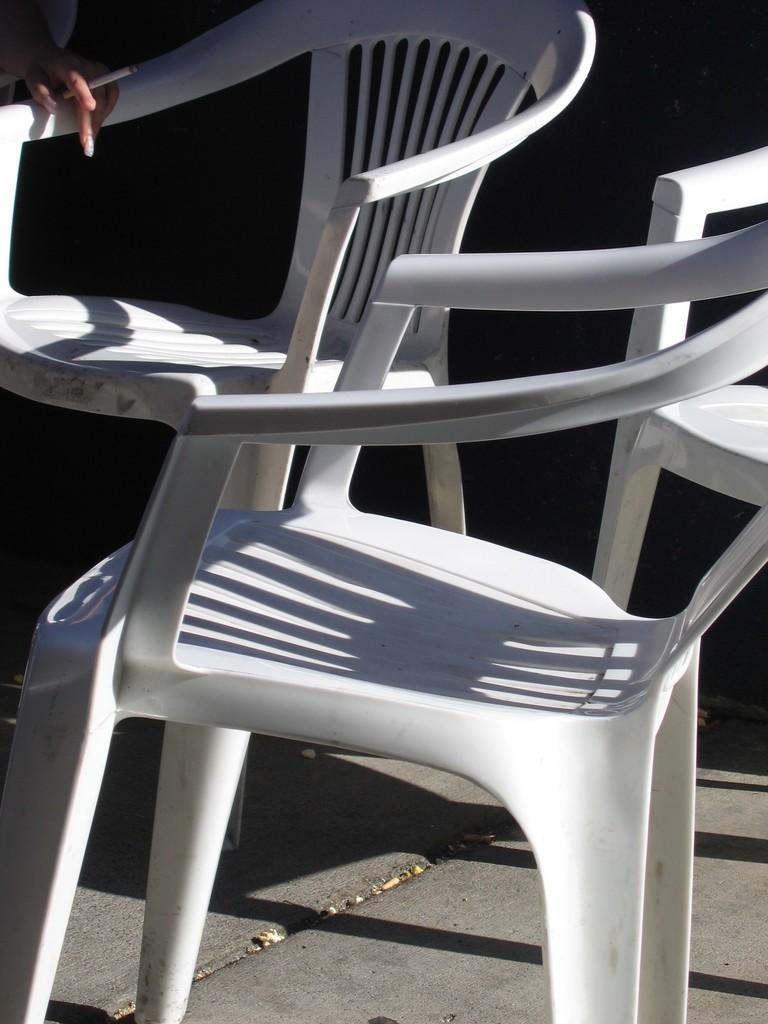In one or two sentences, can you explain what this image depicts? In this picture we can see chairs on the ground, here we can see a person's hand is holding a cigarette and in the background we can see it is dark. 